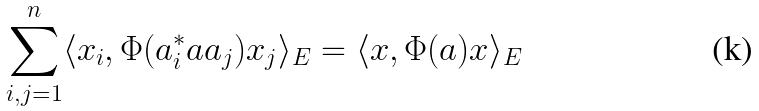Convert formula to latex. <formula><loc_0><loc_0><loc_500><loc_500>\sum _ { i , j = 1 } ^ { n } \langle x _ { i } , \Phi ( a ^ { \ast } _ { i } a a _ { j } ) x _ { j } \rangle _ { E } = \langle x , \Phi ( a ) x \rangle _ { E }</formula> 